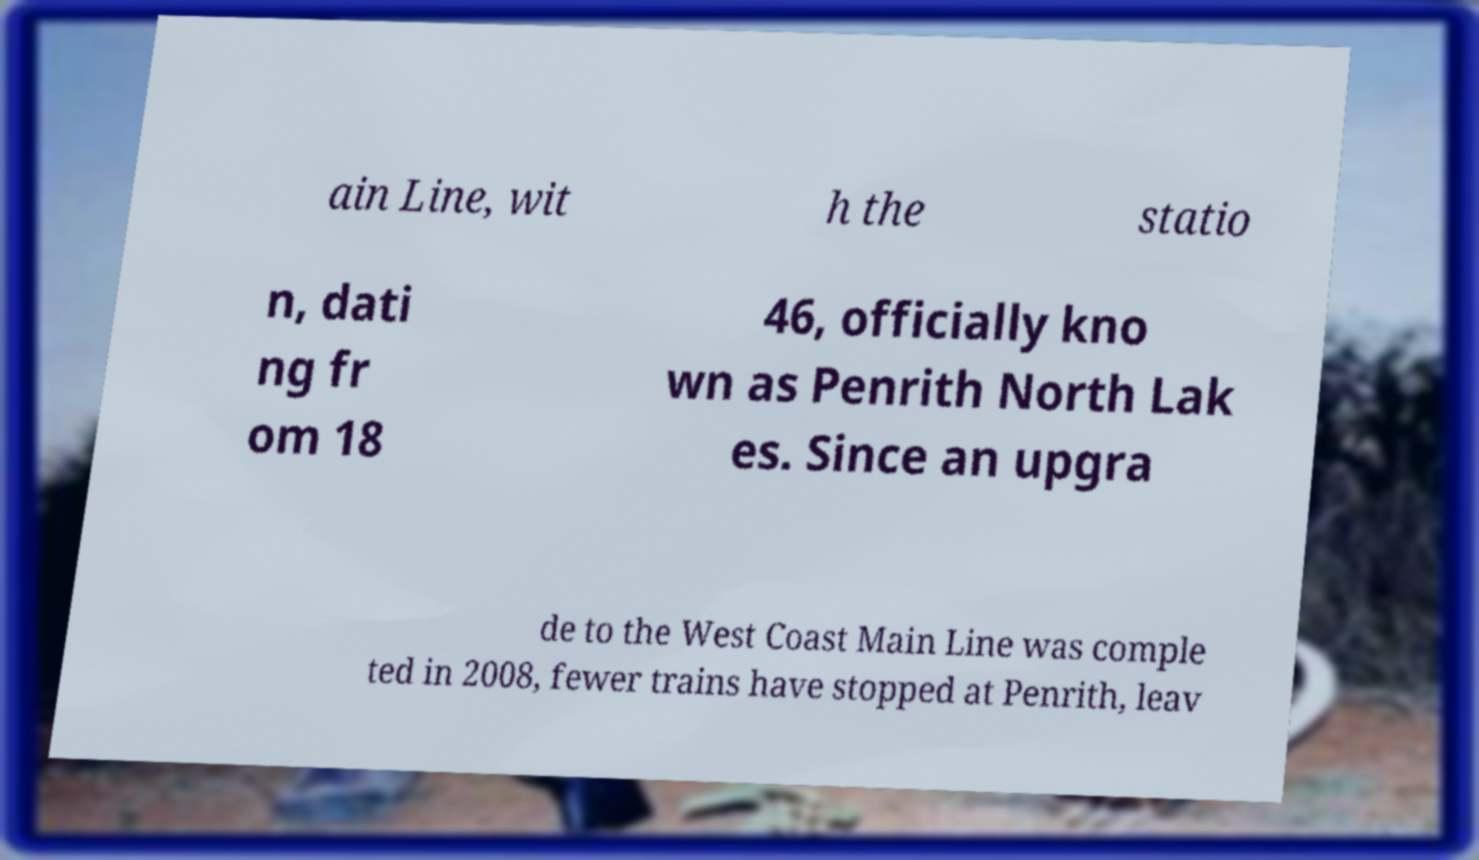There's text embedded in this image that I need extracted. Can you transcribe it verbatim? ain Line, wit h the statio n, dati ng fr om 18 46, officially kno wn as Penrith North Lak es. Since an upgra de to the West Coast Main Line was comple ted in 2008, fewer trains have stopped at Penrith, leav 